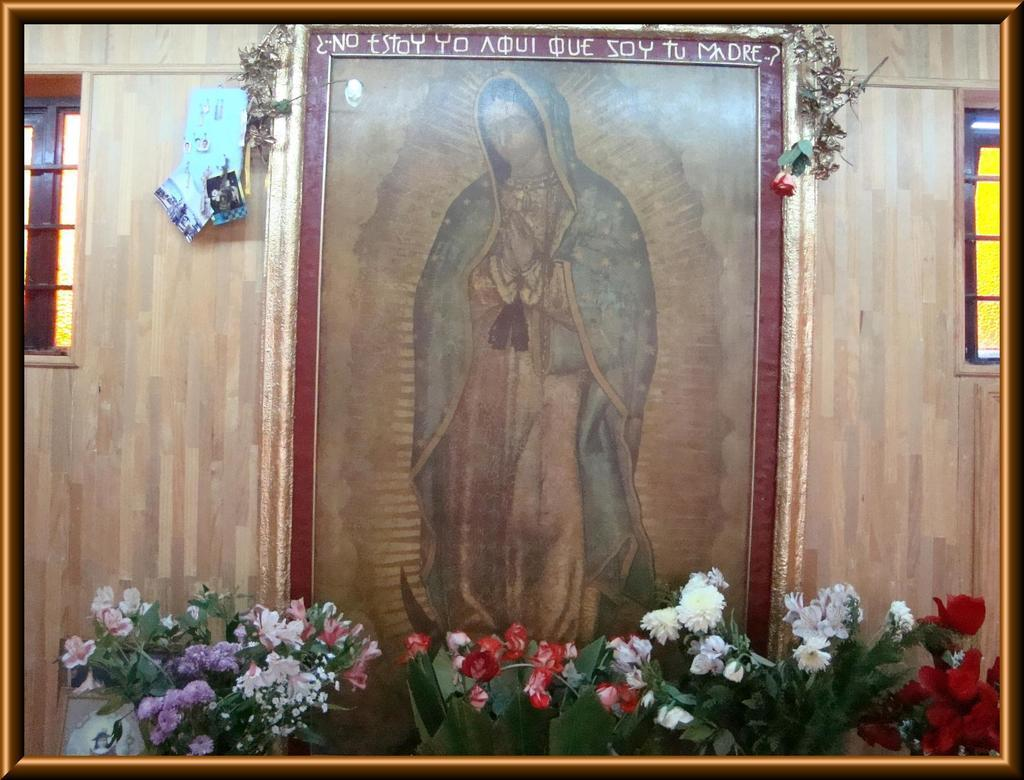What is the main subject of the image? The main subject of the image is a person's photo. What other objects can be seen in the image? There are houseplants, a building, windows, and decorating items in the image. What type of animal can be seen interacting with the plate in the image? There is no plate or animal present in the image. 